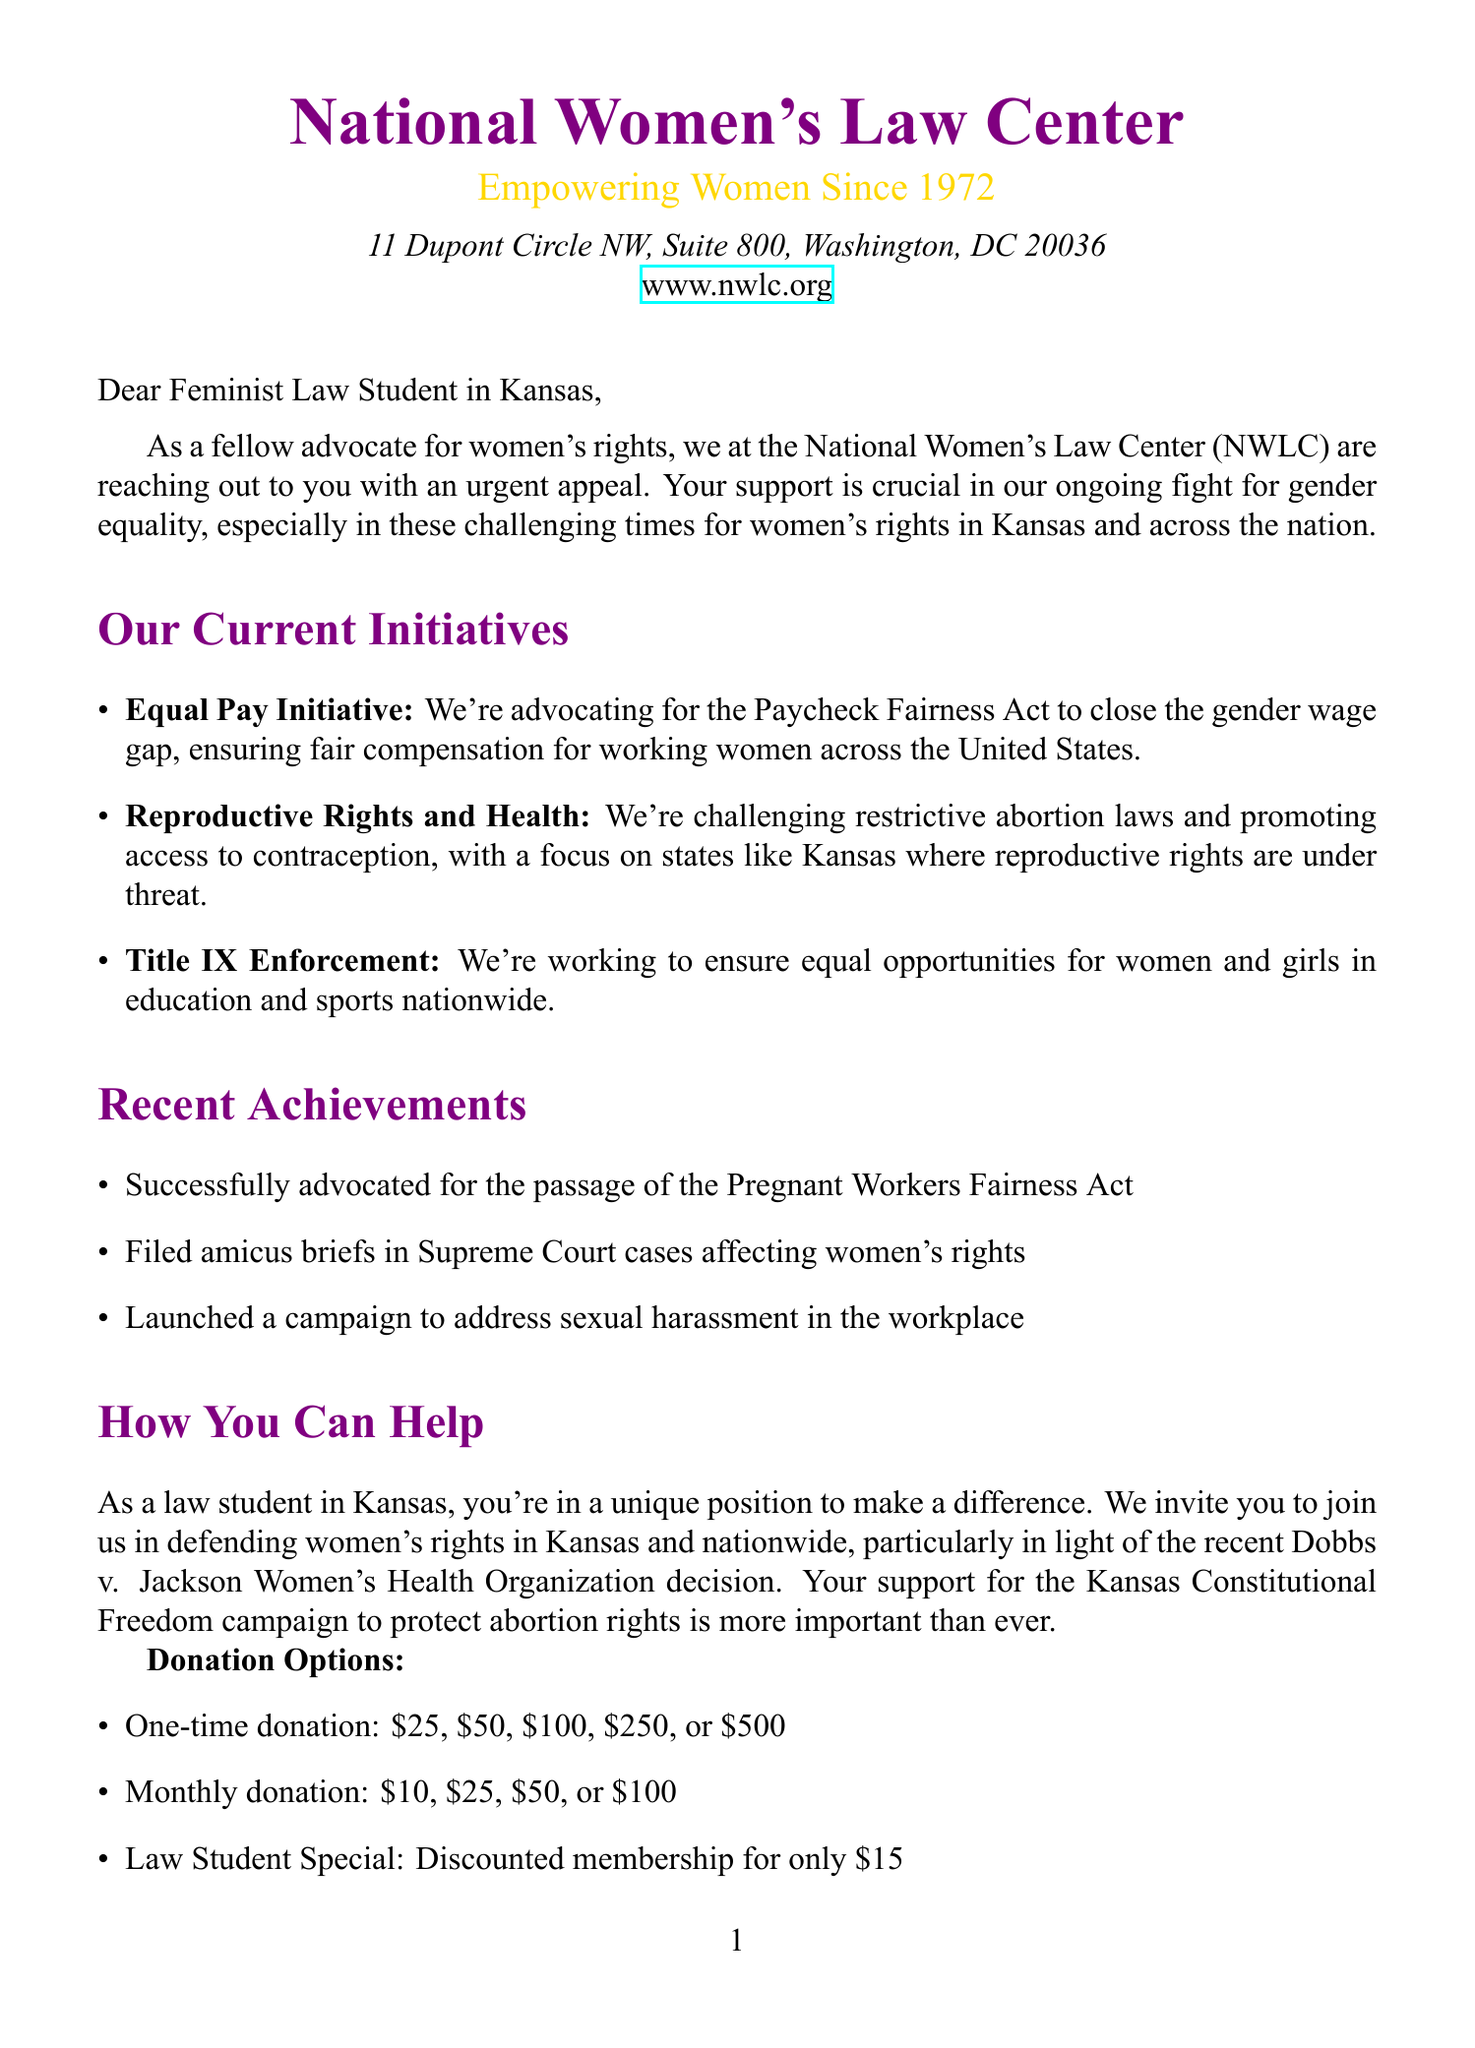What is the full name of the organization? The organization’s full name is specified in the document as the National Women's Law Center.
Answer: National Women's Law Center What year was the National Women's Law Center founded? The founding year is mentioned in the organization details section of the document.
Answer: 1972 What initiative focuses on closing the gender wage gap? The specific initiative related to this issue is described in the current initiatives section of the document.
Answer: Equal Pay Initiative Which recent Supreme Court case is referenced? The relevant case that has impacted women's rights is mentioned in the personalized appeal section.
Answer: Dobbs v. Jackson Women's Health Organization What is the donation amount for the Law Student Special? The special offer for law students is detailed in the donation options section of the document.
Answer: 15 What method can be used for donating besides credit card? The document lists several methods for donations.
Answer: Check What is the URL for the Women’s Rights fact sheet specific to Kansas? The additional resources section provides a link to the fact sheet regarding women's rights in Kansas.
Answer: https://nwlc.org/state/kansas/ What city is the National Women's Law Center located in? The organization’s location is mentioned in the address section of the document.
Answer: Washington, D.C What color is primarily used in the document header? The document employs specific colors for branding.
Answer: Purple 